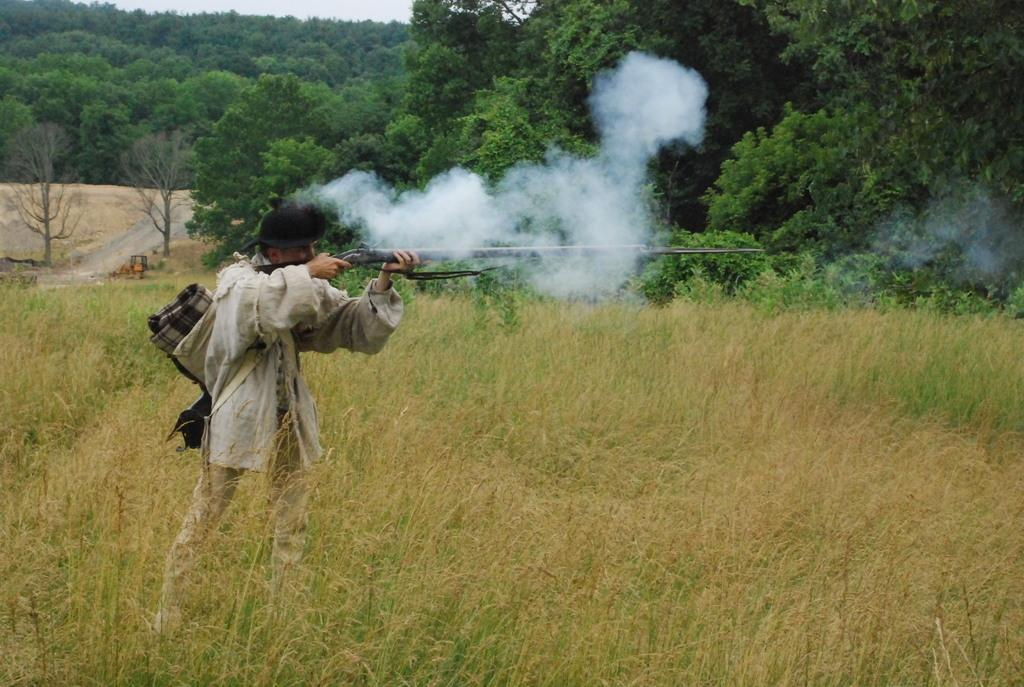What is on the ground in the image? There are plants on the ground in the image. What is the person wearing in the image? The person is wearing a hat in the image. What is the person holding in the image? The person is holding a bag and a gun in the image. What can be seen in the background of the image? There are trees in the background of the background in the image. What is on the left side of the image? There is a road on the left side of the image. What type of lace is used to decorate the person's hat in the image? There is no mention of lace in the image or on the person's hat. What is the reason for the person holding a gun in the image? The image does not provide any context or information about the reason for the person holding a gun. 